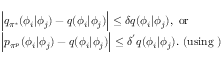Convert formula to latex. <formula><loc_0><loc_0><loc_500><loc_500>\begin{array} { r l } & { \left | q _ { \pi ^ { * } } ( \phi _ { i } | \phi _ { j } ) - q ( \phi _ { i } | \phi _ { j } ) \right | \leq \delta q ( \phi _ { i } | \phi _ { j } ) , o r } \\ & { \left | p _ { \pi ^ { p } } ( \phi _ { i } | \phi _ { j } ) - q ( \phi _ { i } | \phi _ { j } ) \right | \leq \delta ^ { ^ { \prime } } q ( \phi _ { i } | \phi _ { j } ) . ( u \sin g ) } \end{array}</formula> 